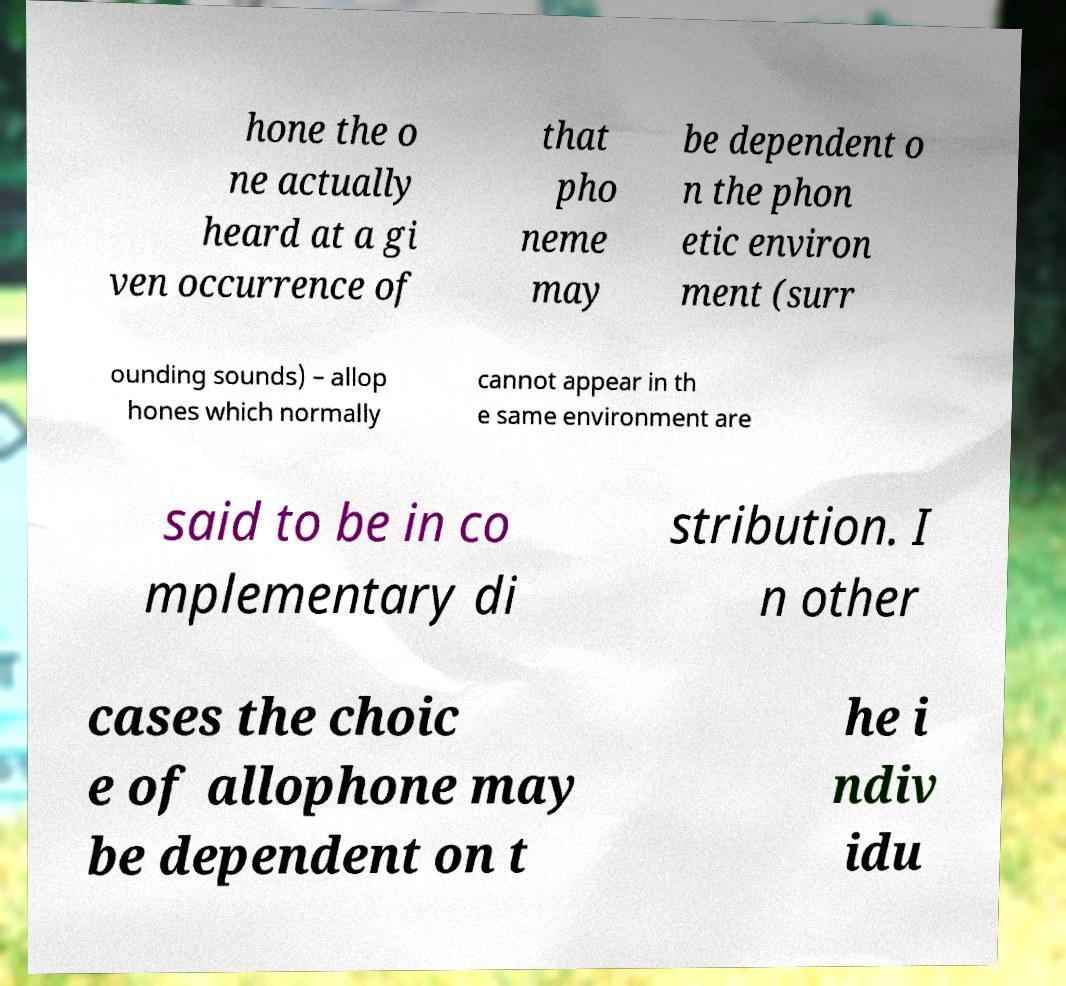I need the written content from this picture converted into text. Can you do that? hone the o ne actually heard at a gi ven occurrence of that pho neme may be dependent o n the phon etic environ ment (surr ounding sounds) – allop hones which normally cannot appear in th e same environment are said to be in co mplementary di stribution. I n other cases the choic e of allophone may be dependent on t he i ndiv idu 